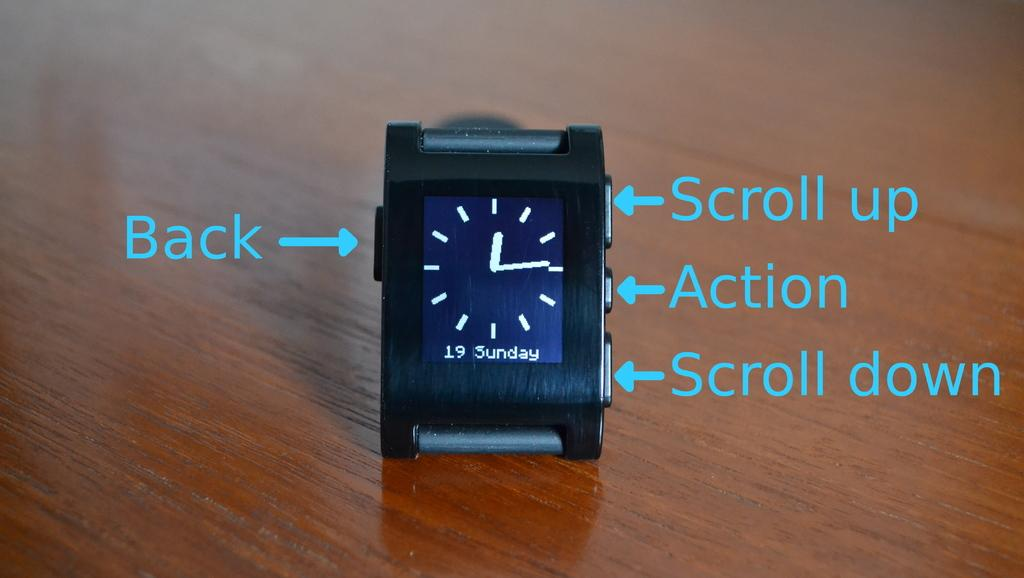What object is placed on the wooden desk in the image? There is a watch placed on a wooden desk in the image. What can be seen on the right side of the image? There are arrows and text on the right side of the image. What can be seen on the left side of the image? There are arrows and text on the left side of the image. What flavor of ice cream does the daughter prefer in the image? There is no mention of ice cream or a daughter in the image, so we cannot determine the flavor of ice cream the daughter prefers. 